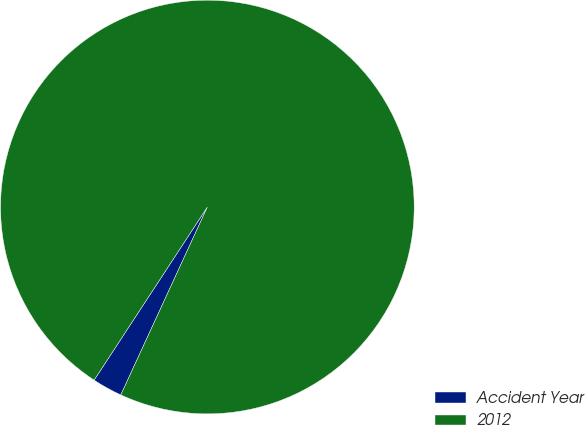Convert chart to OTSL. <chart><loc_0><loc_0><loc_500><loc_500><pie_chart><fcel>Accident Year<fcel>2012<nl><fcel>2.35%<fcel>97.65%<nl></chart> 